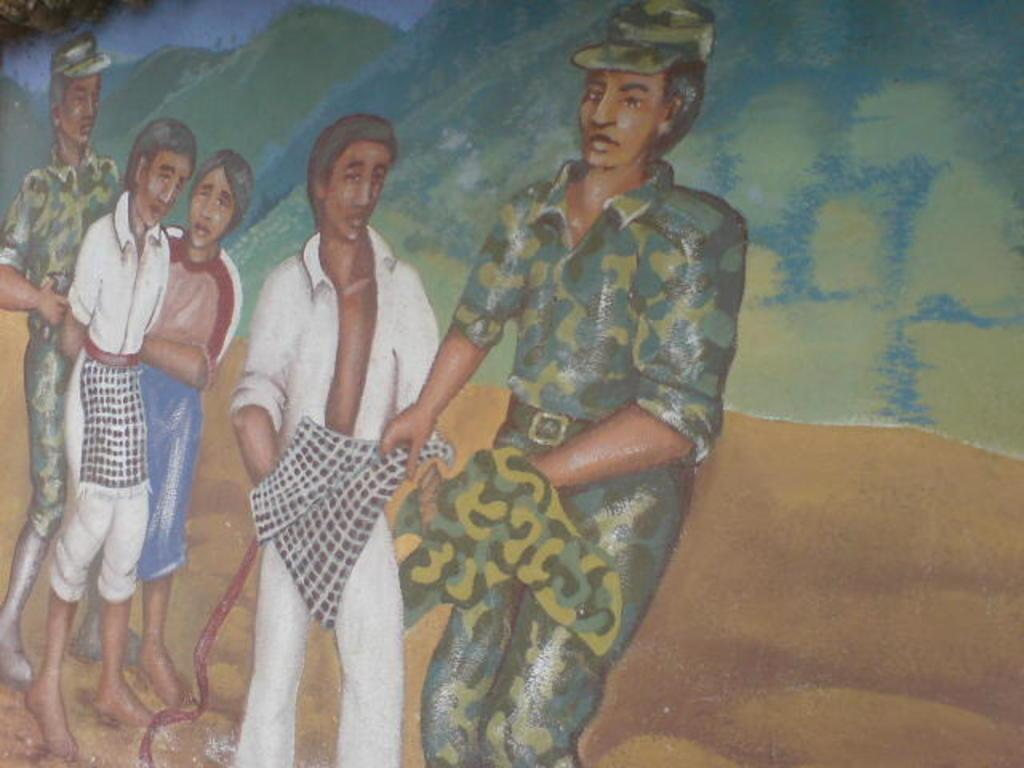What is the main subject of the image? The image contains a painting. What is being depicted in the painting? The painting depicts people. Are there any natural elements in the painting? Yes, the painting includes hills. What else can be seen in the painting's background? The painting features the sky. What type of vessel is being used by the people in the painting? There is no vessel present in the painting; it depicts people, hills, and the sky. Can you tell me how many trucks are visible in the painting? There are no trucks visible in the painting; it features people, hills, and the sky. 